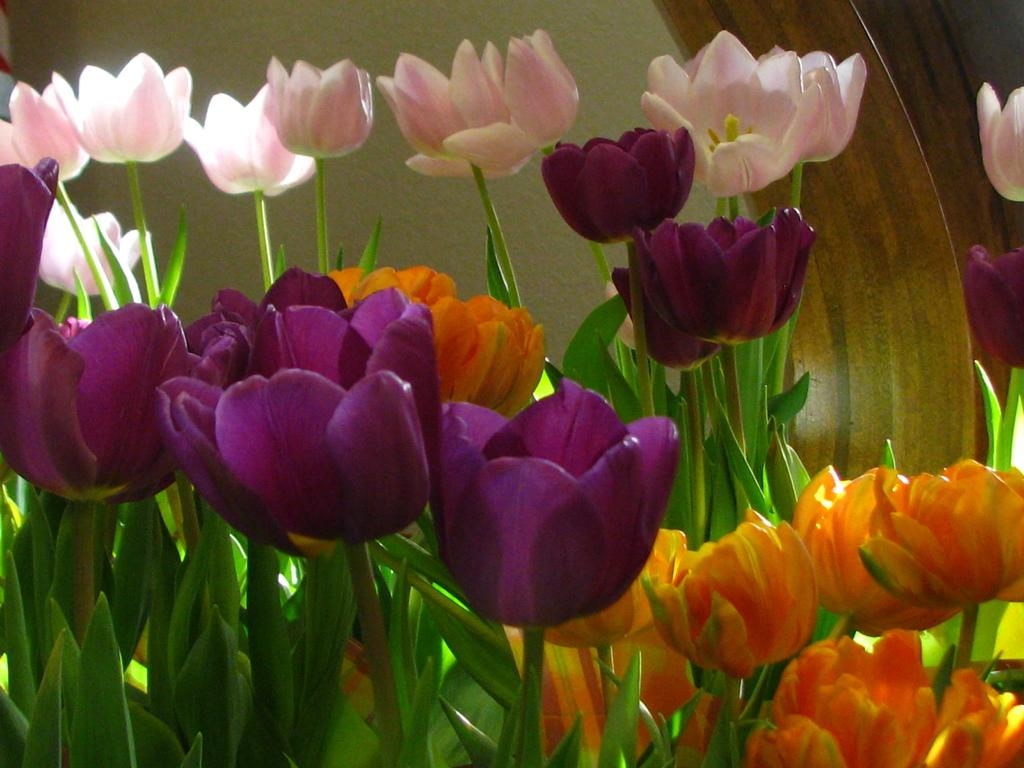What type of flowers are in the image? There are tulips in the image. Can you describe the appearance of the tulips? The tulips have different colors. What can be seen in the background of the image? There is a wall and leaves in the background of the image. How does the image convey a sense of quiet? The image does not convey a sense of quiet, as it features tulips and a background with a wall and leaves. 